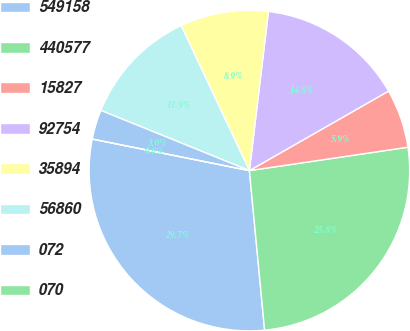<chart> <loc_0><loc_0><loc_500><loc_500><pie_chart><fcel>549158<fcel>440577<fcel>15827<fcel>92754<fcel>35894<fcel>56860<fcel>072<fcel>070<nl><fcel>29.67%<fcel>25.82%<fcel>5.93%<fcel>14.84%<fcel>8.9%<fcel>11.87%<fcel>2.97%<fcel>0.0%<nl></chart> 